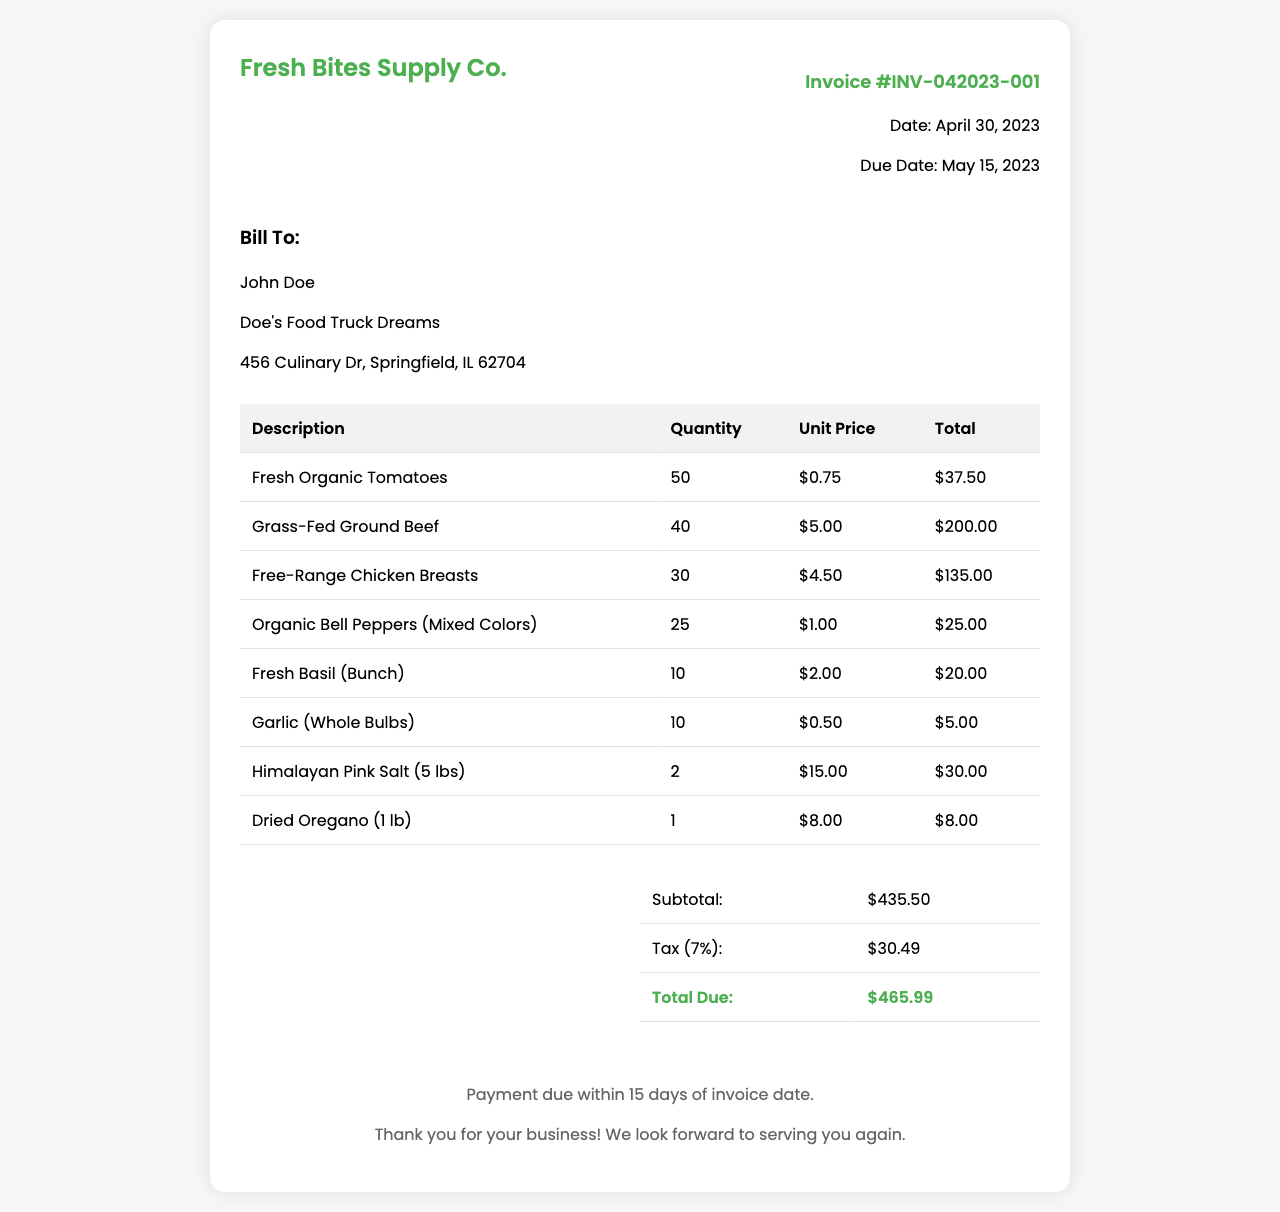What is the invoice number? The invoice number is clearly indicated in the document, which is a unique identifier for this particular transaction.
Answer: INV-042023-001 What is the due date for the invoice? The due date is specified in the invoice details section, indicating when payment is expected.
Answer: May 15, 2023 How many fresh organic tomatoes were purchased? The quantity of fresh organic tomatoes is listed in the itemized table, showing how many were ordered.
Answer: 50 What is the subtotal amount before tax? The subtotal is listed in the summary section before the tax addition is mentioned.
Answer: $435.50 What is the total due after tax? The total due is the final amount listed in the summary section, which includes tax.
Answer: $465.99 Who is the invoice biller? The biller is identified in the "Bill To" section, showing the name associated with the invoice.
Answer: John Doe What type of business is being billed? The nature of the business can be deduced from the business name provided in the bill to section of the invoice.
Answer: Doe's Food Truck Dreams How many pounds of Himalayan Pink Salt were purchased? The quantity is listed next to the item description in the invoice detail section.
Answer: 2 What is the tax percentage applied to the invoice? The tax percentage is clearly stated in the summary section, which indicates how tax is calculated on the subtotal.
Answer: 7% 